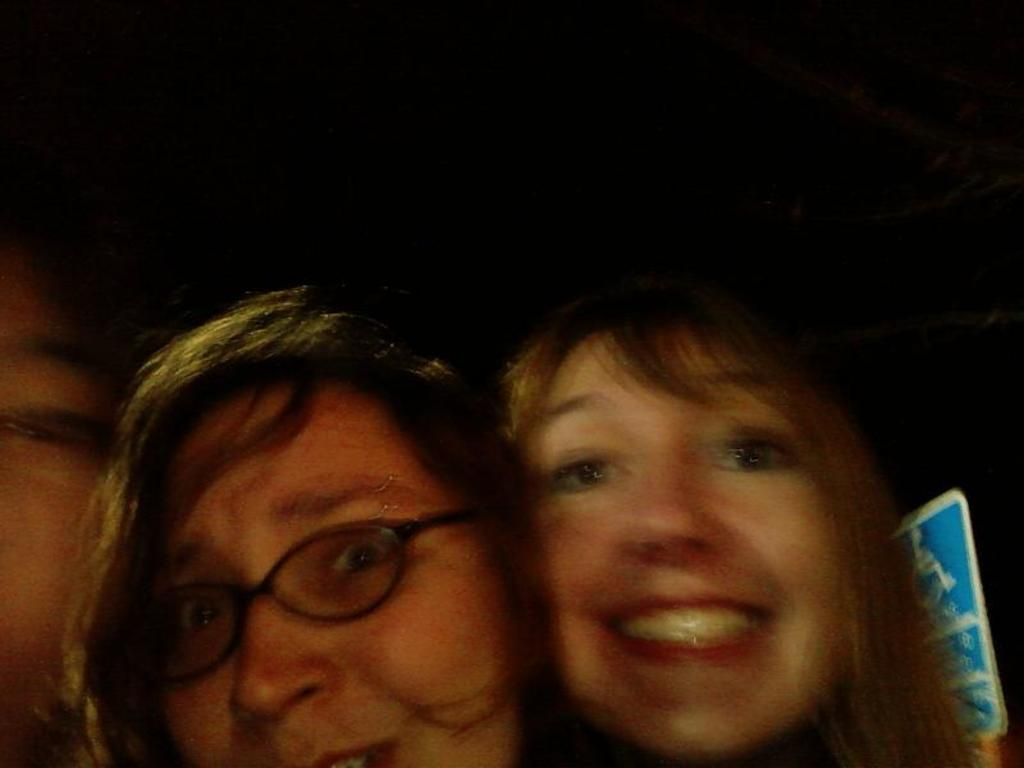Who or what can be seen in the image? There are people in the image. What object is located on the right side of the image? There is a board on the right side of the image. What type of chain is being used by the people in the image? There is no chain visible in the image; it only shows people and a board. Can you hear a whistle in the image? There is no sound or indication of a whistle in the image. 